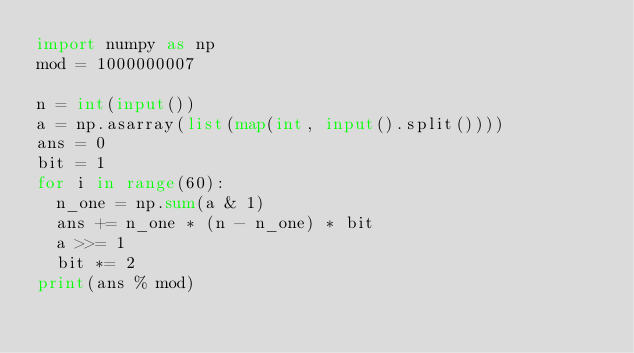<code> <loc_0><loc_0><loc_500><loc_500><_Python_>import numpy as np
mod = 1000000007

n = int(input())
a = np.asarray(list(map(int, input().split())))
ans = 0
bit = 1
for i in range(60):
  n_one = np.sum(a & 1)
  ans += n_one * (n - n_one) * bit
  a >>= 1
  bit *= 2
print(ans % mod)</code> 